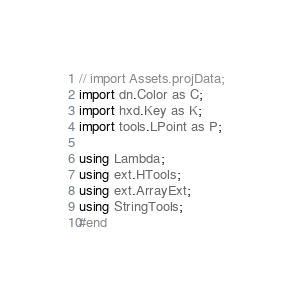<code> <loc_0><loc_0><loc_500><loc_500><_Haxe_>// import Assets.projData;
import dn.Color as C;
import hxd.Key as K;
import tools.LPoint as P;

using Lambda;
using ext.HTools;
using ext.ArrayExt;
using StringTools;
#end</code> 